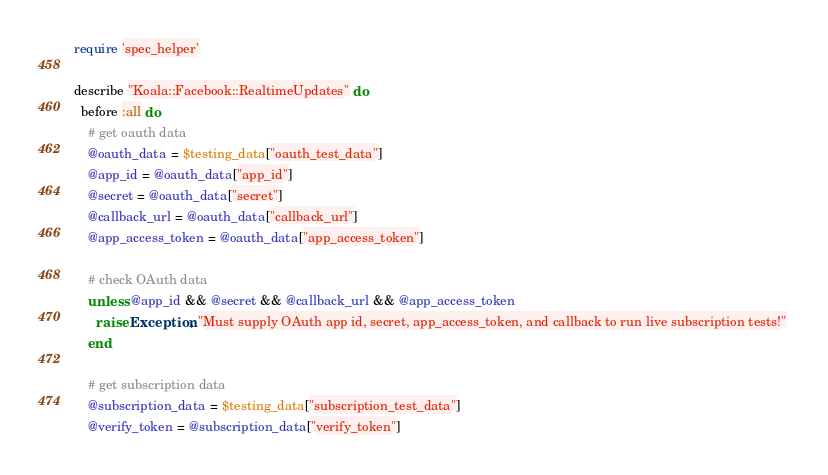Convert code to text. <code><loc_0><loc_0><loc_500><loc_500><_Ruby_>require 'spec_helper'

describe "Koala::Facebook::RealtimeUpdates" do
  before :all do
    # get oauth data
    @oauth_data = $testing_data["oauth_test_data"]
    @app_id = @oauth_data["app_id"]
    @secret = @oauth_data["secret"]
    @callback_url = @oauth_data["callback_url"]
    @app_access_token = @oauth_data["app_access_token"]
    
    # check OAuth data
    unless @app_id && @secret && @callback_url && @app_access_token
      raise Exception, "Must supply OAuth app id, secret, app_access_token, and callback to run live subscription tests!" 
    end
    
    # get subscription data
    @subscription_data = $testing_data["subscription_test_data"]
    @verify_token = @subscription_data["verify_token"]</code> 